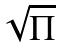<formula> <loc_0><loc_0><loc_500><loc_500>\sqrt { \Pi }</formula> 